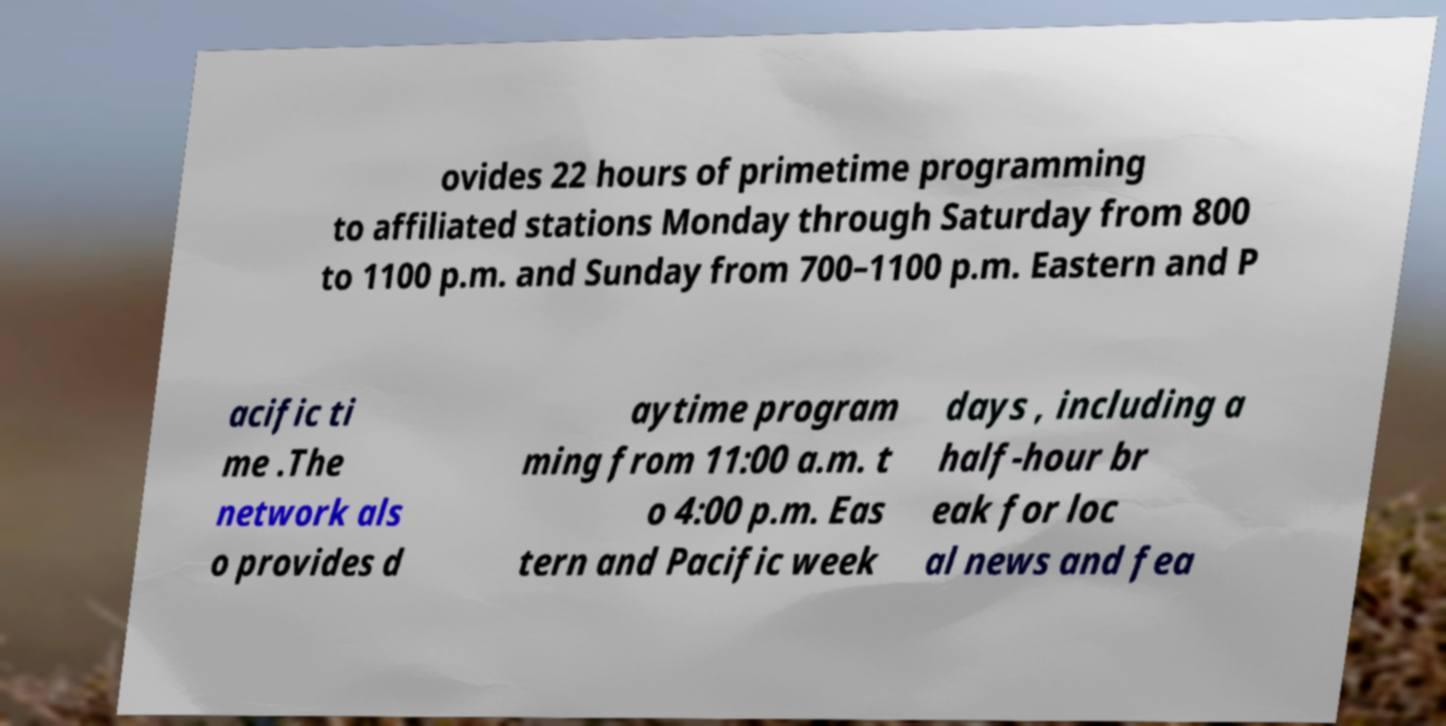Please read and relay the text visible in this image. What does it say? ovides 22 hours of primetime programming to affiliated stations Monday through Saturday from 800 to 1100 p.m. and Sunday from 700–1100 p.m. Eastern and P acific ti me .The network als o provides d aytime program ming from 11:00 a.m. t o 4:00 p.m. Eas tern and Pacific week days , including a half-hour br eak for loc al news and fea 